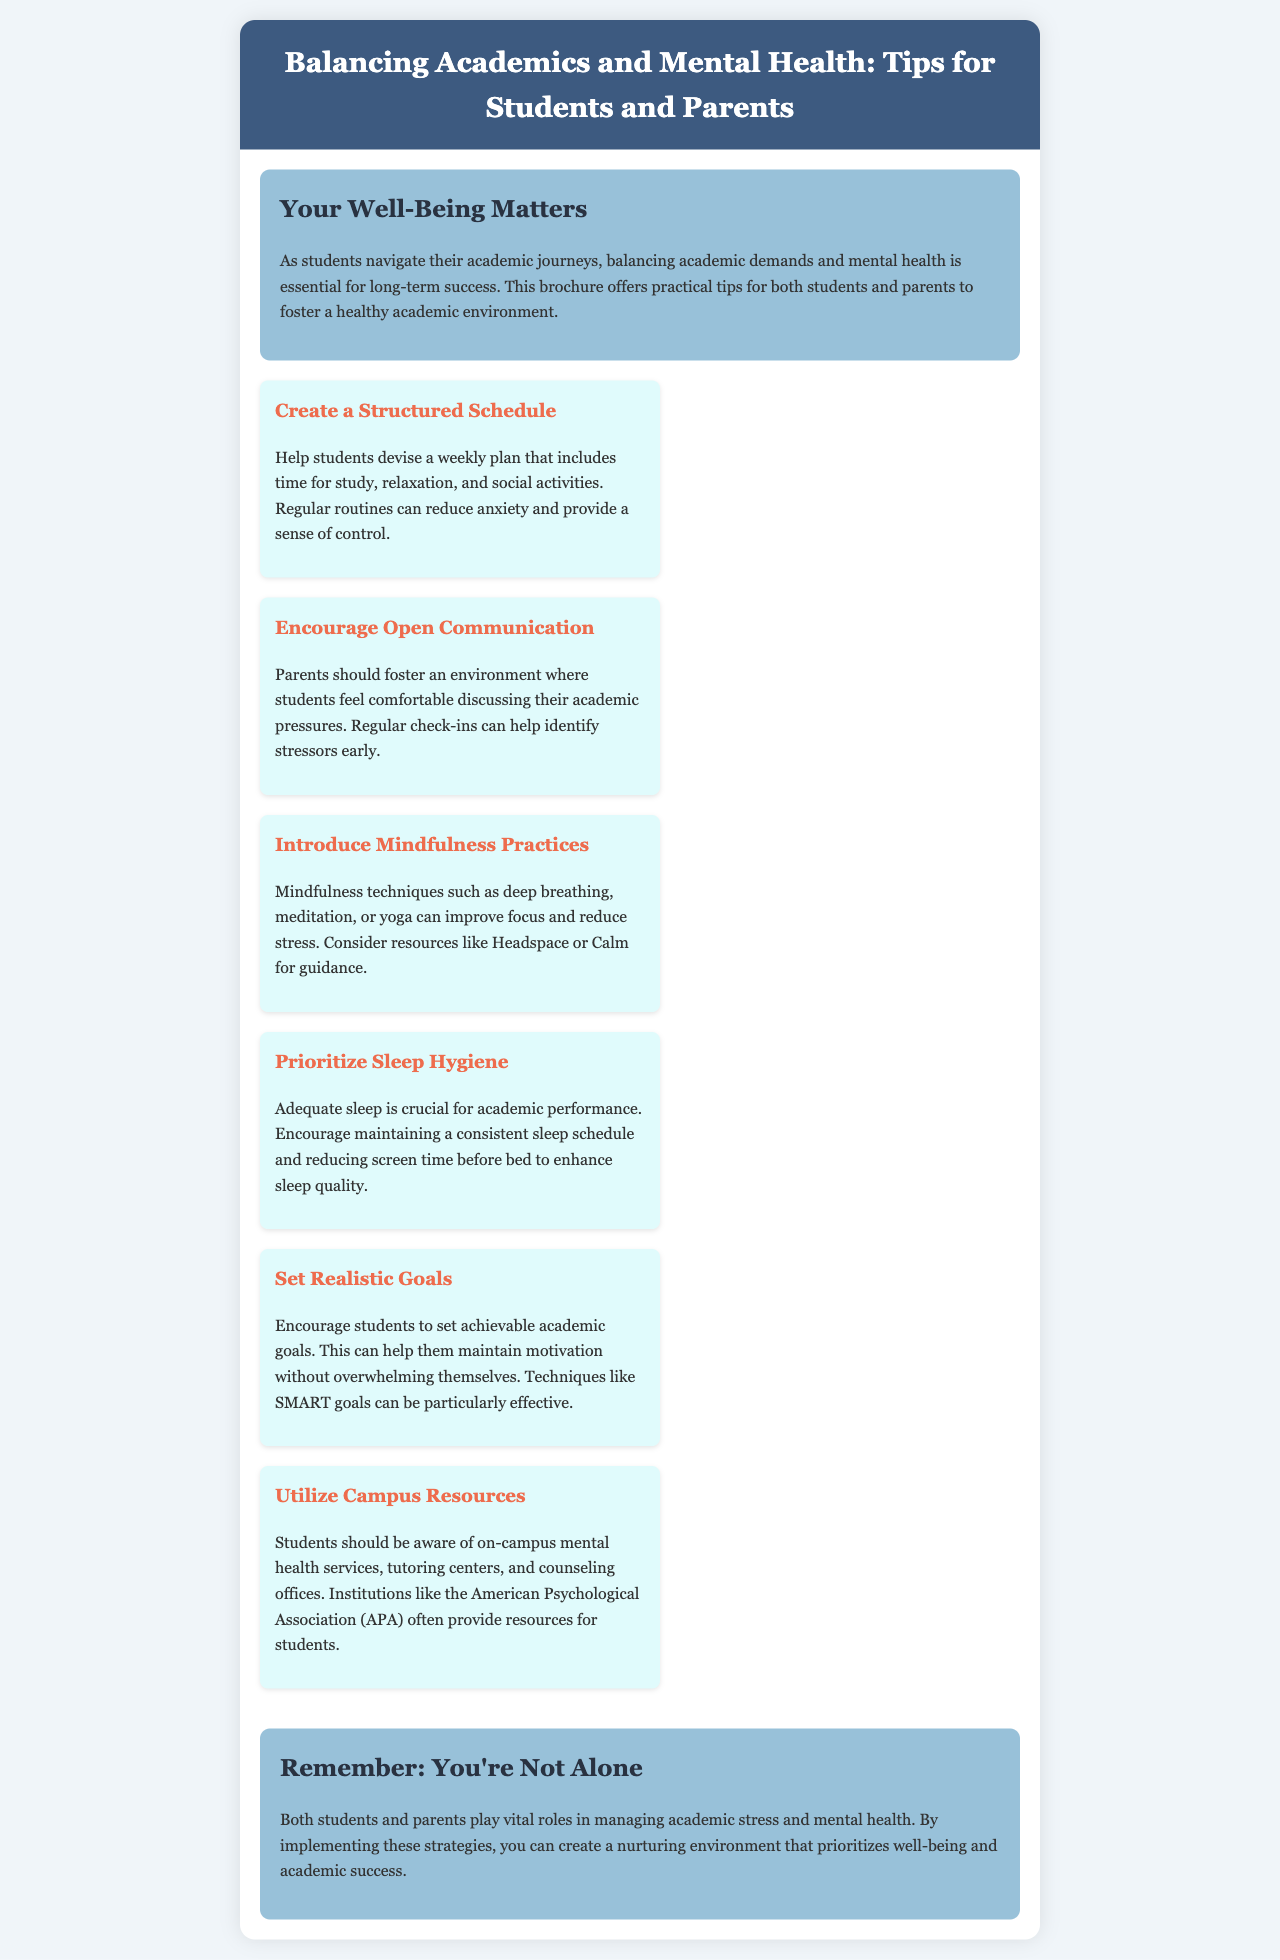What is the title of the brochure? The title is found in the header section and clearly states the topic the brochure addresses.
Answer: Balancing Academics and Mental Health: Tips for Students and Parents How many tips are provided in the document? Counting the sections designated as tips shows the number of recommendations made.
Answer: Six What is suggested for improving sleep quality? The document provides a specific strategy related to sleep hygiene for better academic performance.
Answer: Consistent sleep schedule What does the brochure recommend for fostering communication? This message is emphasized in one of the tips that outline the importance of discussing academic pressures.
Answer: Open communication Which mindfulness practices are mentioned? Mindfulness techniques are elaborated in one of the tips, highlighting specific activities that can help reduce stress.
Answer: Deep breathing, meditation, yoga What is emphasized about academic goals? The brochure discusses a method to help students set goals that will keep them motivated without excess stress.
Answer: Realistic goals 